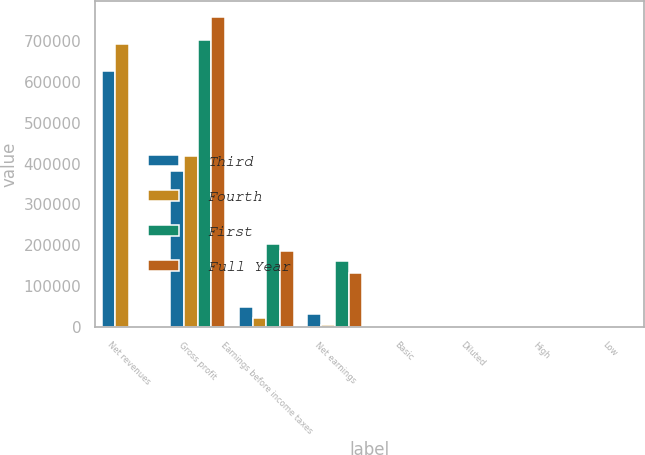Convert chart to OTSL. <chart><loc_0><loc_0><loc_500><loc_500><stacked_bar_chart><ecel><fcel>Net revenues<fcel>Gross profit<fcel>Earnings before income taxes<fcel>Net earnings<fcel>Basic<fcel>Diluted<fcel>High<fcel>Low<nl><fcel>Third<fcel>625267<fcel>381815<fcel>49600<fcel>32890<fcel>0.2<fcel>0.19<fcel>30.24<fcel>27.04<nl><fcel>Fourth<fcel>691408<fcel>418196<fcel>21961<fcel>4801<fcel>0.03<fcel>0.03<fcel>33.43<fcel>28.1<nl><fcel>First<fcel>33.46<fcel>702016<fcel>203921<fcel>161580<fcel>1.04<fcel>0.95<fcel>33.49<fcel>25.25<nl><fcel>Full Year<fcel>33.46<fcel>758909<fcel>186900<fcel>133732<fcel>0.91<fcel>0.84<fcel>30.68<fcel>25.25<nl></chart> 